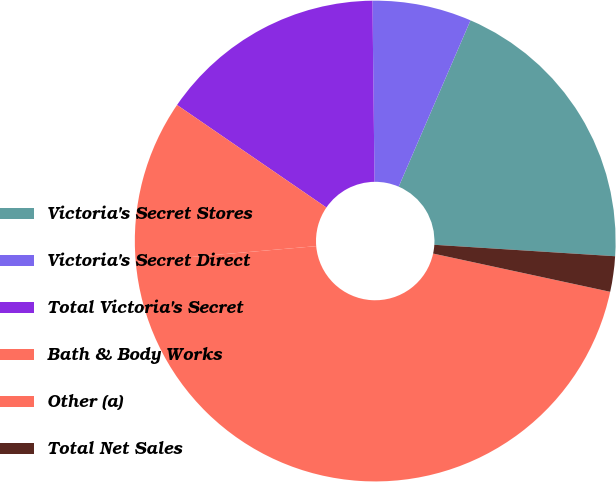<chart> <loc_0><loc_0><loc_500><loc_500><pie_chart><fcel>Victoria's Secret Stores<fcel>Victoria's Secret Direct<fcel>Total Victoria's Secret<fcel>Bath & Body Works<fcel>Other (a)<fcel>Total Net Sales<nl><fcel>19.52%<fcel>6.67%<fcel>15.24%<fcel>10.95%<fcel>45.24%<fcel>2.38%<nl></chart> 